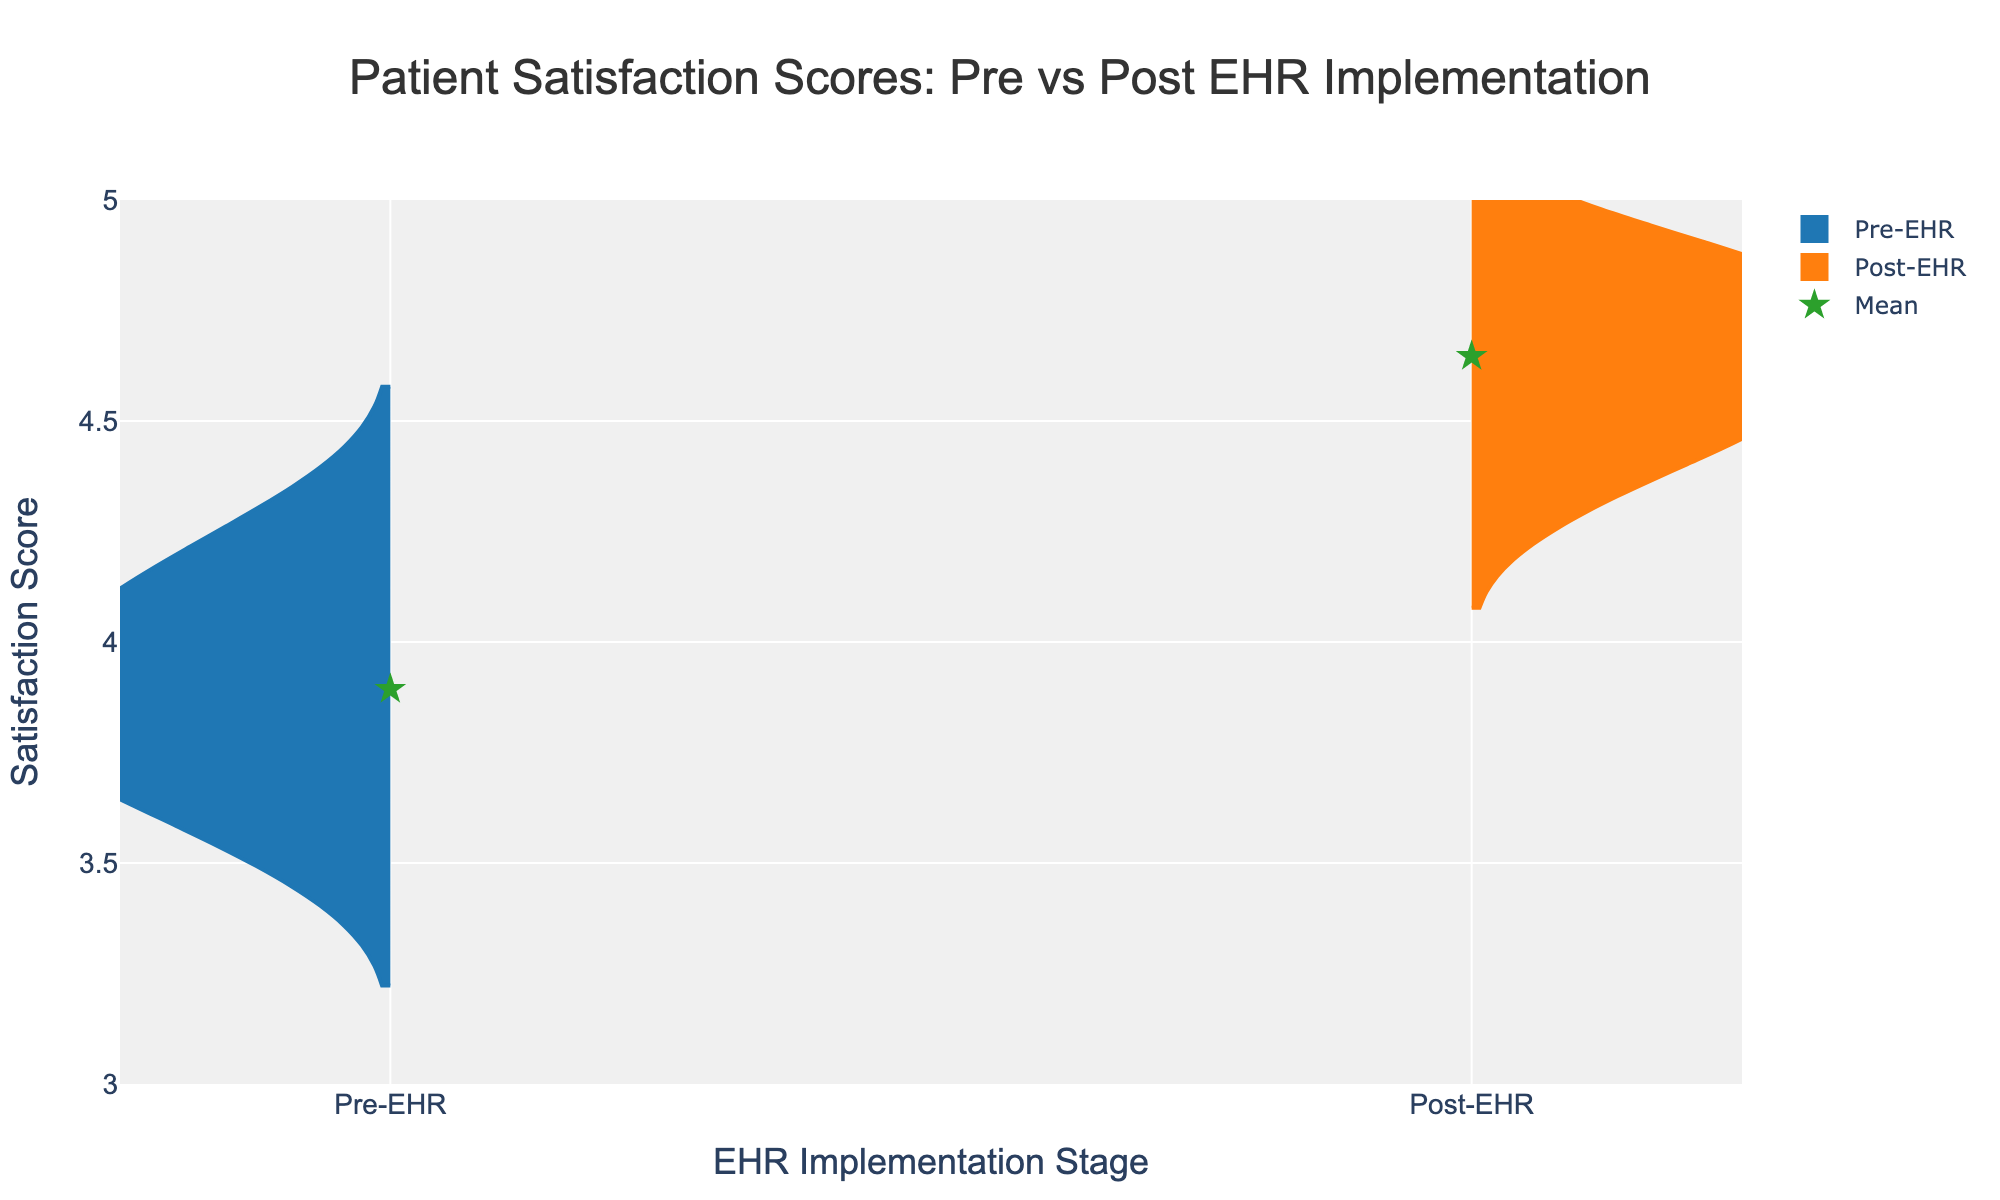What is the title of the figure? The title is located at the top of the figure and reads "Patient Satisfaction Scores: Pre vs Post EHR Implementation".
Answer: Patient Satisfaction Scores: Pre vs Post EHR Implementation What are the x-axis titles? The x-axis titles are placed along the x-axis and read "EHR Implementation Stage".
Answer: EHR Implementation Stage What color represents the Pre-EHR satisfaction scores? The Pre-EHR satisfaction scores are shown in blue, as indicated by the line color and fill color of the left side of the violins.
Answer: Blue What is the range of the y-axis? The y-axis displays satisfaction scores ranging from 3 to 5, as indicated by the axis labels and grid lines.
Answer: 3 to 5 Which implementation stage has a higher mean satisfaction score? By comparing the mean points marked by green stars, the Post-EHR implementation stage has a higher mean satisfaction score.
Answer: Post-EHR How many patients' satisfaction scores are displayed in total? Each split violin represents data from the same 15 patients pre- and post-EHR implementation, totaling 30 data points.
Answer: 30 What's the average satisfaction score for the Post-EHR implementation? The mean point for the Post-EHR stage is shown as a green star on the positive side of the plot.
Answer: Approximately 4.6 How do the shapes of the violins for Pre-EHR and Post-EHR compare? The Post-EHR violin is wider and shifts higher on the y-axis compared to the Pre-EHR violin, indicating higher and more varied satisfaction scores.
Answer: Post-EHR is higher and more varied Do any satisfaction scores repeat for both Pre-EHR and Post-EHR stages? By visually inspecting the positions of the points within each violin, some scores like 4.7 appear in both implementations.
Answer: Yes What can be inferred about patient satisfaction after the implementation of EHR? The Post-EHR violin is shifted higher and is wider, suggesting an increase in both the average satisfaction and its variability.
Answer: Satisfaction increased 